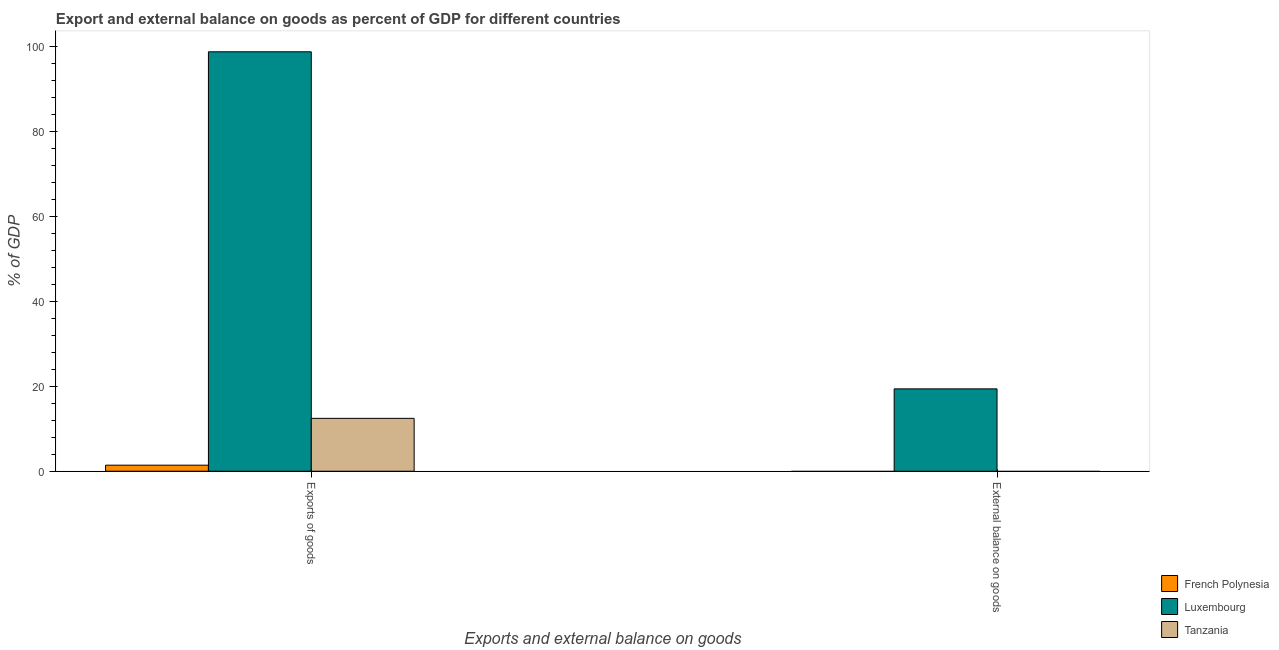How many different coloured bars are there?
Offer a terse response. 3. How many bars are there on the 2nd tick from the left?
Your answer should be very brief. 1. How many bars are there on the 2nd tick from the right?
Your response must be concise. 3. What is the label of the 1st group of bars from the left?
Your answer should be very brief. Exports of goods. What is the export of goods as percentage of gdp in French Polynesia?
Your answer should be very brief. 1.42. Across all countries, what is the maximum external balance on goods as percentage of gdp?
Your response must be concise. 19.38. Across all countries, what is the minimum external balance on goods as percentage of gdp?
Provide a succinct answer. 0. In which country was the export of goods as percentage of gdp maximum?
Provide a succinct answer. Luxembourg. What is the total export of goods as percentage of gdp in the graph?
Give a very brief answer. 112.57. What is the difference between the export of goods as percentage of gdp in French Polynesia and that in Tanzania?
Make the answer very short. -11.02. What is the difference between the export of goods as percentage of gdp in Luxembourg and the external balance on goods as percentage of gdp in Tanzania?
Your answer should be compact. 98.71. What is the average external balance on goods as percentage of gdp per country?
Give a very brief answer. 6.46. What is the difference between the external balance on goods as percentage of gdp and export of goods as percentage of gdp in Luxembourg?
Make the answer very short. -79.33. What is the ratio of the export of goods as percentage of gdp in French Polynesia to that in Luxembourg?
Your response must be concise. 0.01. What is the difference between two consecutive major ticks on the Y-axis?
Your answer should be very brief. 20. Does the graph contain grids?
Give a very brief answer. No. Where does the legend appear in the graph?
Offer a very short reply. Bottom right. How many legend labels are there?
Your response must be concise. 3. What is the title of the graph?
Your answer should be very brief. Export and external balance on goods as percent of GDP for different countries. Does "South Africa" appear as one of the legend labels in the graph?
Provide a succinct answer. No. What is the label or title of the X-axis?
Your answer should be compact. Exports and external balance on goods. What is the label or title of the Y-axis?
Offer a terse response. % of GDP. What is the % of GDP of French Polynesia in Exports of goods?
Give a very brief answer. 1.42. What is the % of GDP in Luxembourg in Exports of goods?
Give a very brief answer. 98.71. What is the % of GDP of Tanzania in Exports of goods?
Make the answer very short. 12.44. What is the % of GDP of Luxembourg in External balance on goods?
Ensure brevity in your answer.  19.38. What is the % of GDP in Tanzania in External balance on goods?
Your answer should be very brief. 0. Across all Exports and external balance on goods, what is the maximum % of GDP of French Polynesia?
Give a very brief answer. 1.42. Across all Exports and external balance on goods, what is the maximum % of GDP of Luxembourg?
Your answer should be very brief. 98.71. Across all Exports and external balance on goods, what is the maximum % of GDP of Tanzania?
Your answer should be very brief. 12.44. Across all Exports and external balance on goods, what is the minimum % of GDP of French Polynesia?
Give a very brief answer. 0. Across all Exports and external balance on goods, what is the minimum % of GDP in Luxembourg?
Your answer should be compact. 19.38. Across all Exports and external balance on goods, what is the minimum % of GDP in Tanzania?
Provide a short and direct response. 0. What is the total % of GDP in French Polynesia in the graph?
Give a very brief answer. 1.42. What is the total % of GDP of Luxembourg in the graph?
Your answer should be compact. 118.09. What is the total % of GDP of Tanzania in the graph?
Keep it short and to the point. 12.44. What is the difference between the % of GDP of Luxembourg in Exports of goods and that in External balance on goods?
Your response must be concise. 79.33. What is the difference between the % of GDP in French Polynesia in Exports of goods and the % of GDP in Luxembourg in External balance on goods?
Your answer should be compact. -17.96. What is the average % of GDP in French Polynesia per Exports and external balance on goods?
Keep it short and to the point. 0.71. What is the average % of GDP in Luxembourg per Exports and external balance on goods?
Ensure brevity in your answer.  59.05. What is the average % of GDP in Tanzania per Exports and external balance on goods?
Provide a succinct answer. 6.22. What is the difference between the % of GDP in French Polynesia and % of GDP in Luxembourg in Exports of goods?
Provide a succinct answer. -97.29. What is the difference between the % of GDP in French Polynesia and % of GDP in Tanzania in Exports of goods?
Offer a very short reply. -11.02. What is the difference between the % of GDP in Luxembourg and % of GDP in Tanzania in Exports of goods?
Keep it short and to the point. 86.27. What is the ratio of the % of GDP of Luxembourg in Exports of goods to that in External balance on goods?
Provide a succinct answer. 5.09. What is the difference between the highest and the second highest % of GDP of Luxembourg?
Offer a terse response. 79.33. What is the difference between the highest and the lowest % of GDP in French Polynesia?
Keep it short and to the point. 1.42. What is the difference between the highest and the lowest % of GDP in Luxembourg?
Offer a terse response. 79.33. What is the difference between the highest and the lowest % of GDP of Tanzania?
Offer a terse response. 12.44. 